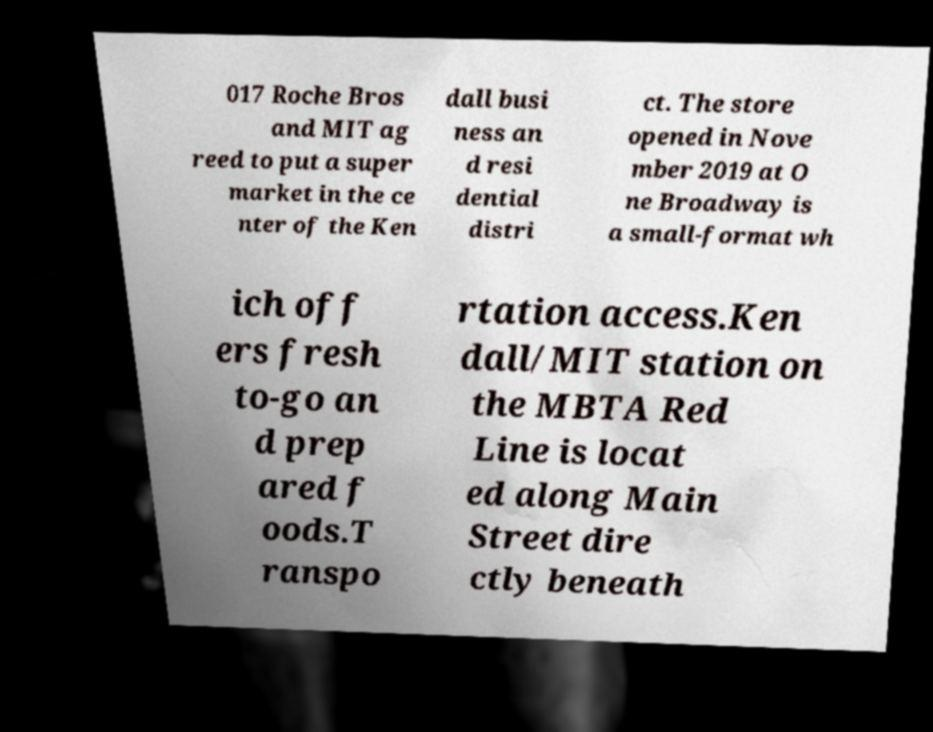Please read and relay the text visible in this image. What does it say? 017 Roche Bros and MIT ag reed to put a super market in the ce nter of the Ken dall busi ness an d resi dential distri ct. The store opened in Nove mber 2019 at O ne Broadway is a small-format wh ich off ers fresh to-go an d prep ared f oods.T ranspo rtation access.Ken dall/MIT station on the MBTA Red Line is locat ed along Main Street dire ctly beneath 